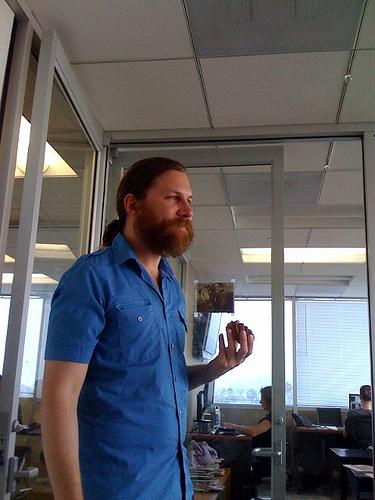What office reprieve does this man avail himself of? Please explain your reasoning. coffee break. The man in the office is holding a snack and taking a coffee break. 